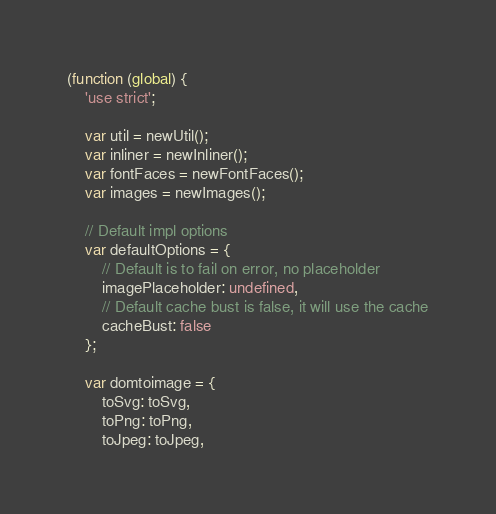Convert code to text. <code><loc_0><loc_0><loc_500><loc_500><_JavaScript_>(function (global) {
    'use strict';

    var util = newUtil();
    var inliner = newInliner();
    var fontFaces = newFontFaces();
    var images = newImages();

    // Default impl options
    var defaultOptions = {
        // Default is to fail on error, no placeholder
        imagePlaceholder: undefined,
        // Default cache bust is false, it will use the cache
        cacheBust: false
    };

    var domtoimage = {
        toSvg: toSvg,
        toPng: toPng,
        toJpeg: toJpeg,</code> 